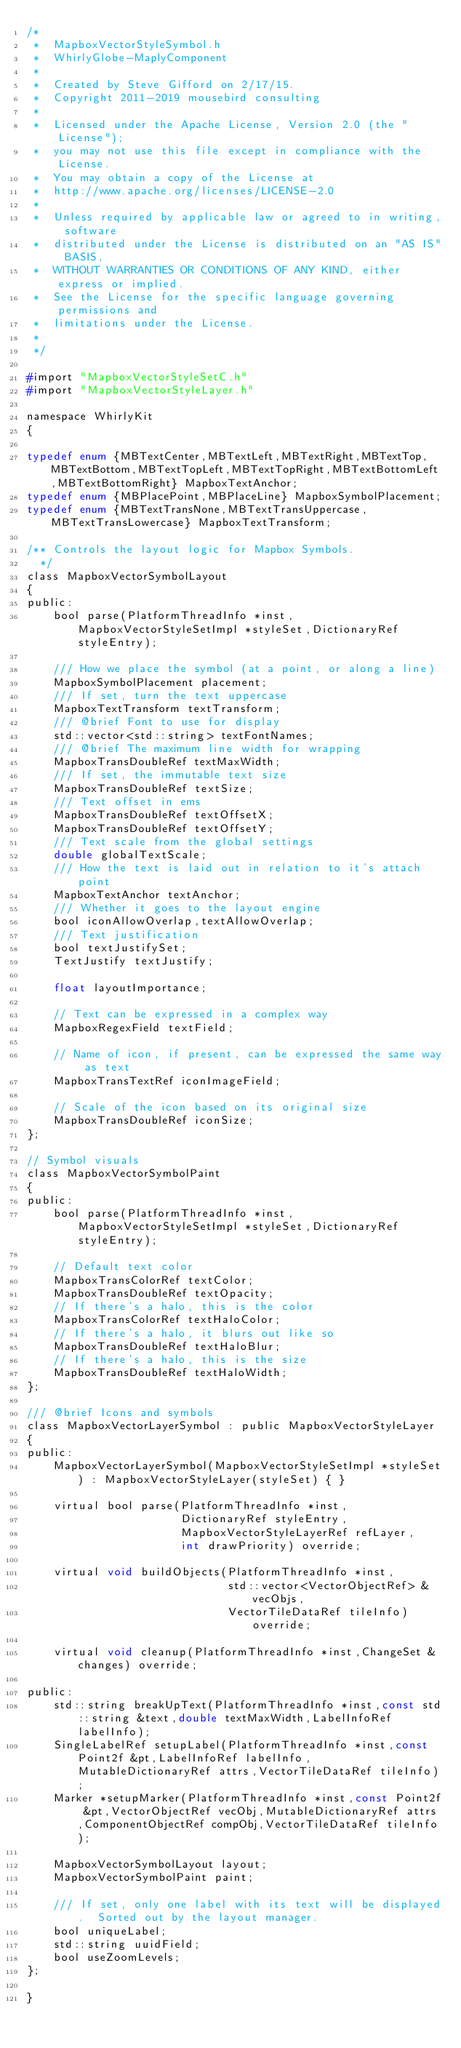Convert code to text. <code><loc_0><loc_0><loc_500><loc_500><_C_>/*
 *  MapboxVectorStyleSymbol.h
 *  WhirlyGlobe-MaplyComponent
 *
 *  Created by Steve Gifford on 2/17/15.
 *  Copyright 2011-2019 mousebird consulting
 *
 *  Licensed under the Apache License, Version 2.0 (the "License");
 *  you may not use this file except in compliance with the License.
 *  You may obtain a copy of the License at
 *  http://www.apache.org/licenses/LICENSE-2.0
 *
 *  Unless required by applicable law or agreed to in writing, software
 *  distributed under the License is distributed on an "AS IS" BASIS,
 *  WITHOUT WARRANTIES OR CONDITIONS OF ANY KIND, either express or implied.
 *  See the License for the specific language governing permissions and
 *  limitations under the License.
 *
 */

#import "MapboxVectorStyleSetC.h"
#import "MapboxVectorStyleLayer.h"

namespace WhirlyKit
{

typedef enum {MBTextCenter,MBTextLeft,MBTextRight,MBTextTop,MBTextBottom,MBTextTopLeft,MBTextTopRight,MBTextBottomLeft,MBTextBottomRight} MapboxTextAnchor;
typedef enum {MBPlacePoint,MBPlaceLine} MapboxSymbolPlacement;
typedef enum {MBTextTransNone,MBTextTransUppercase,MBTextTransLowercase} MapboxTextTransform;

/** Controls the layout logic for Mapbox Symbols.
  */
class MapboxVectorSymbolLayout
{
public:
    bool parse(PlatformThreadInfo *inst,MapboxVectorStyleSetImpl *styleSet,DictionaryRef styleEntry);

    /// How we place the symbol (at a point, or along a line)
    MapboxSymbolPlacement placement;
    /// If set, turn the text uppercase
    MapboxTextTransform textTransform;
    /// @brief Font to use for display
    std::vector<std::string> textFontNames;
    /// @brief The maximum line width for wrapping
    MapboxTransDoubleRef textMaxWidth;
    /// If set, the immutable text size
    MapboxTransDoubleRef textSize;
    /// Text offset in ems
    MapboxTransDoubleRef textOffsetX;
    MapboxTransDoubleRef textOffsetY;
    /// Text scale from the global settings
    double globalTextScale;
    /// How the text is laid out in relation to it's attach point
    MapboxTextAnchor textAnchor;
    /// Whether it goes to the layout engine
    bool iconAllowOverlap,textAllowOverlap;
    /// Text justification
    bool textJustifySet;
    TextJustify textJustify;
    
    float layoutImportance;
        
    // Text can be expressed in a complex way
    MapboxRegexField textField;

    // Name of icon, if present, can be expressed the same way as text
    MapboxTransTextRef iconImageField;

    // Scale of the icon based on its original size
    MapboxTransDoubleRef iconSize;
};

// Symbol visuals
class MapboxVectorSymbolPaint
{
public:
    bool parse(PlatformThreadInfo *inst,MapboxVectorStyleSetImpl *styleSet,DictionaryRef styleEntry);

    // Default text color
    MapboxTransColorRef textColor;
    MapboxTransDoubleRef textOpacity;
    // If there's a halo, this is the color
    MapboxTransColorRef textHaloColor;
    // If there's a halo, it blurs out like so
    MapboxTransDoubleRef textHaloBlur;
    // If there's a halo, this is the size
    MapboxTransDoubleRef textHaloWidth;
};

/// @brief Icons and symbols
class MapboxVectorLayerSymbol : public MapboxVectorStyleLayer
{
public:
    MapboxVectorLayerSymbol(MapboxVectorStyleSetImpl *styleSet) : MapboxVectorStyleLayer(styleSet) { }

    virtual bool parse(PlatformThreadInfo *inst,
                       DictionaryRef styleEntry,
                       MapboxVectorStyleLayerRef refLayer,
                       int drawPriority) override;
    
    virtual void buildObjects(PlatformThreadInfo *inst,
                              std::vector<VectorObjectRef> &vecObjs,
                              VectorTileDataRef tileInfo) override;
    
    virtual void cleanup(PlatformThreadInfo *inst,ChangeSet &changes) override;

public:
    std::string breakUpText(PlatformThreadInfo *inst,const std::string &text,double textMaxWidth,LabelInfoRef labelInfo);
    SingleLabelRef setupLabel(PlatformThreadInfo *inst,const Point2f &pt,LabelInfoRef labelInfo,MutableDictionaryRef attrs,VectorTileDataRef tileInfo);
    Marker *setupMarker(PlatformThreadInfo *inst,const Point2f &pt,VectorObjectRef vecObj,MutableDictionaryRef attrs,ComponentObjectRef compObj,VectorTileDataRef tileInfo);
    
    MapboxVectorSymbolLayout layout;
    MapboxVectorSymbolPaint paint;

    /// If set, only one label with its text will be displayed.  Sorted out by the layout manager.
    bool uniqueLabel;
    std::string uuidField;
    bool useZoomLevels;
};

}
</code> 